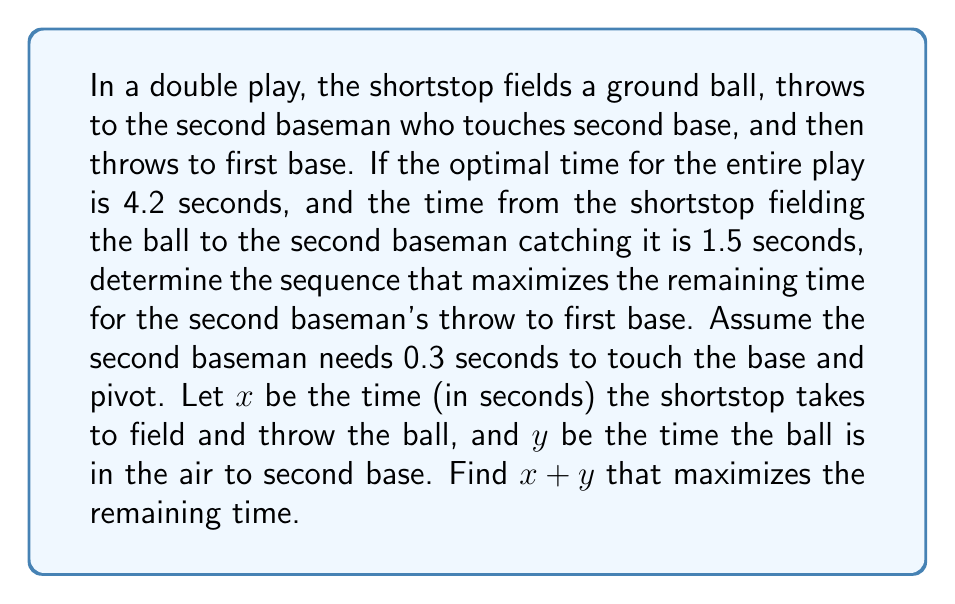Provide a solution to this math problem. Let's approach this step-by-step:

1) The total time for the double play is 4.2 seconds.

2) We know that the time from the shortstop fielding the ball to the second baseman catching it is 1.5 seconds. This can be represented as $x + y = 1.5$, where:
   $x$ = time for shortstop to field and throw
   $y$ = time for ball to travel to second base

3) The second baseman needs 0.3 seconds to touch the base and pivot.

4) Let's call the remaining time for the throw to first base $z$.

5) We can set up the equation:
   $x + y + 0.3 + z = 4.2$

6) Substituting $x + y = 1.5$ from step 2:
   $1.5 + 0.3 + z = 4.2$
   $1.8 + z = 4.2$
   $z = 4.2 - 1.8 = 2.4$

7) Therefore, to maximize the time for the throw to first base, we need to minimize $x + y$.

8) Since we know $x + y = 1.5$, this is already the minimum possible value that maximizes the remaining time.
Answer: $x + y = 1.5$ 